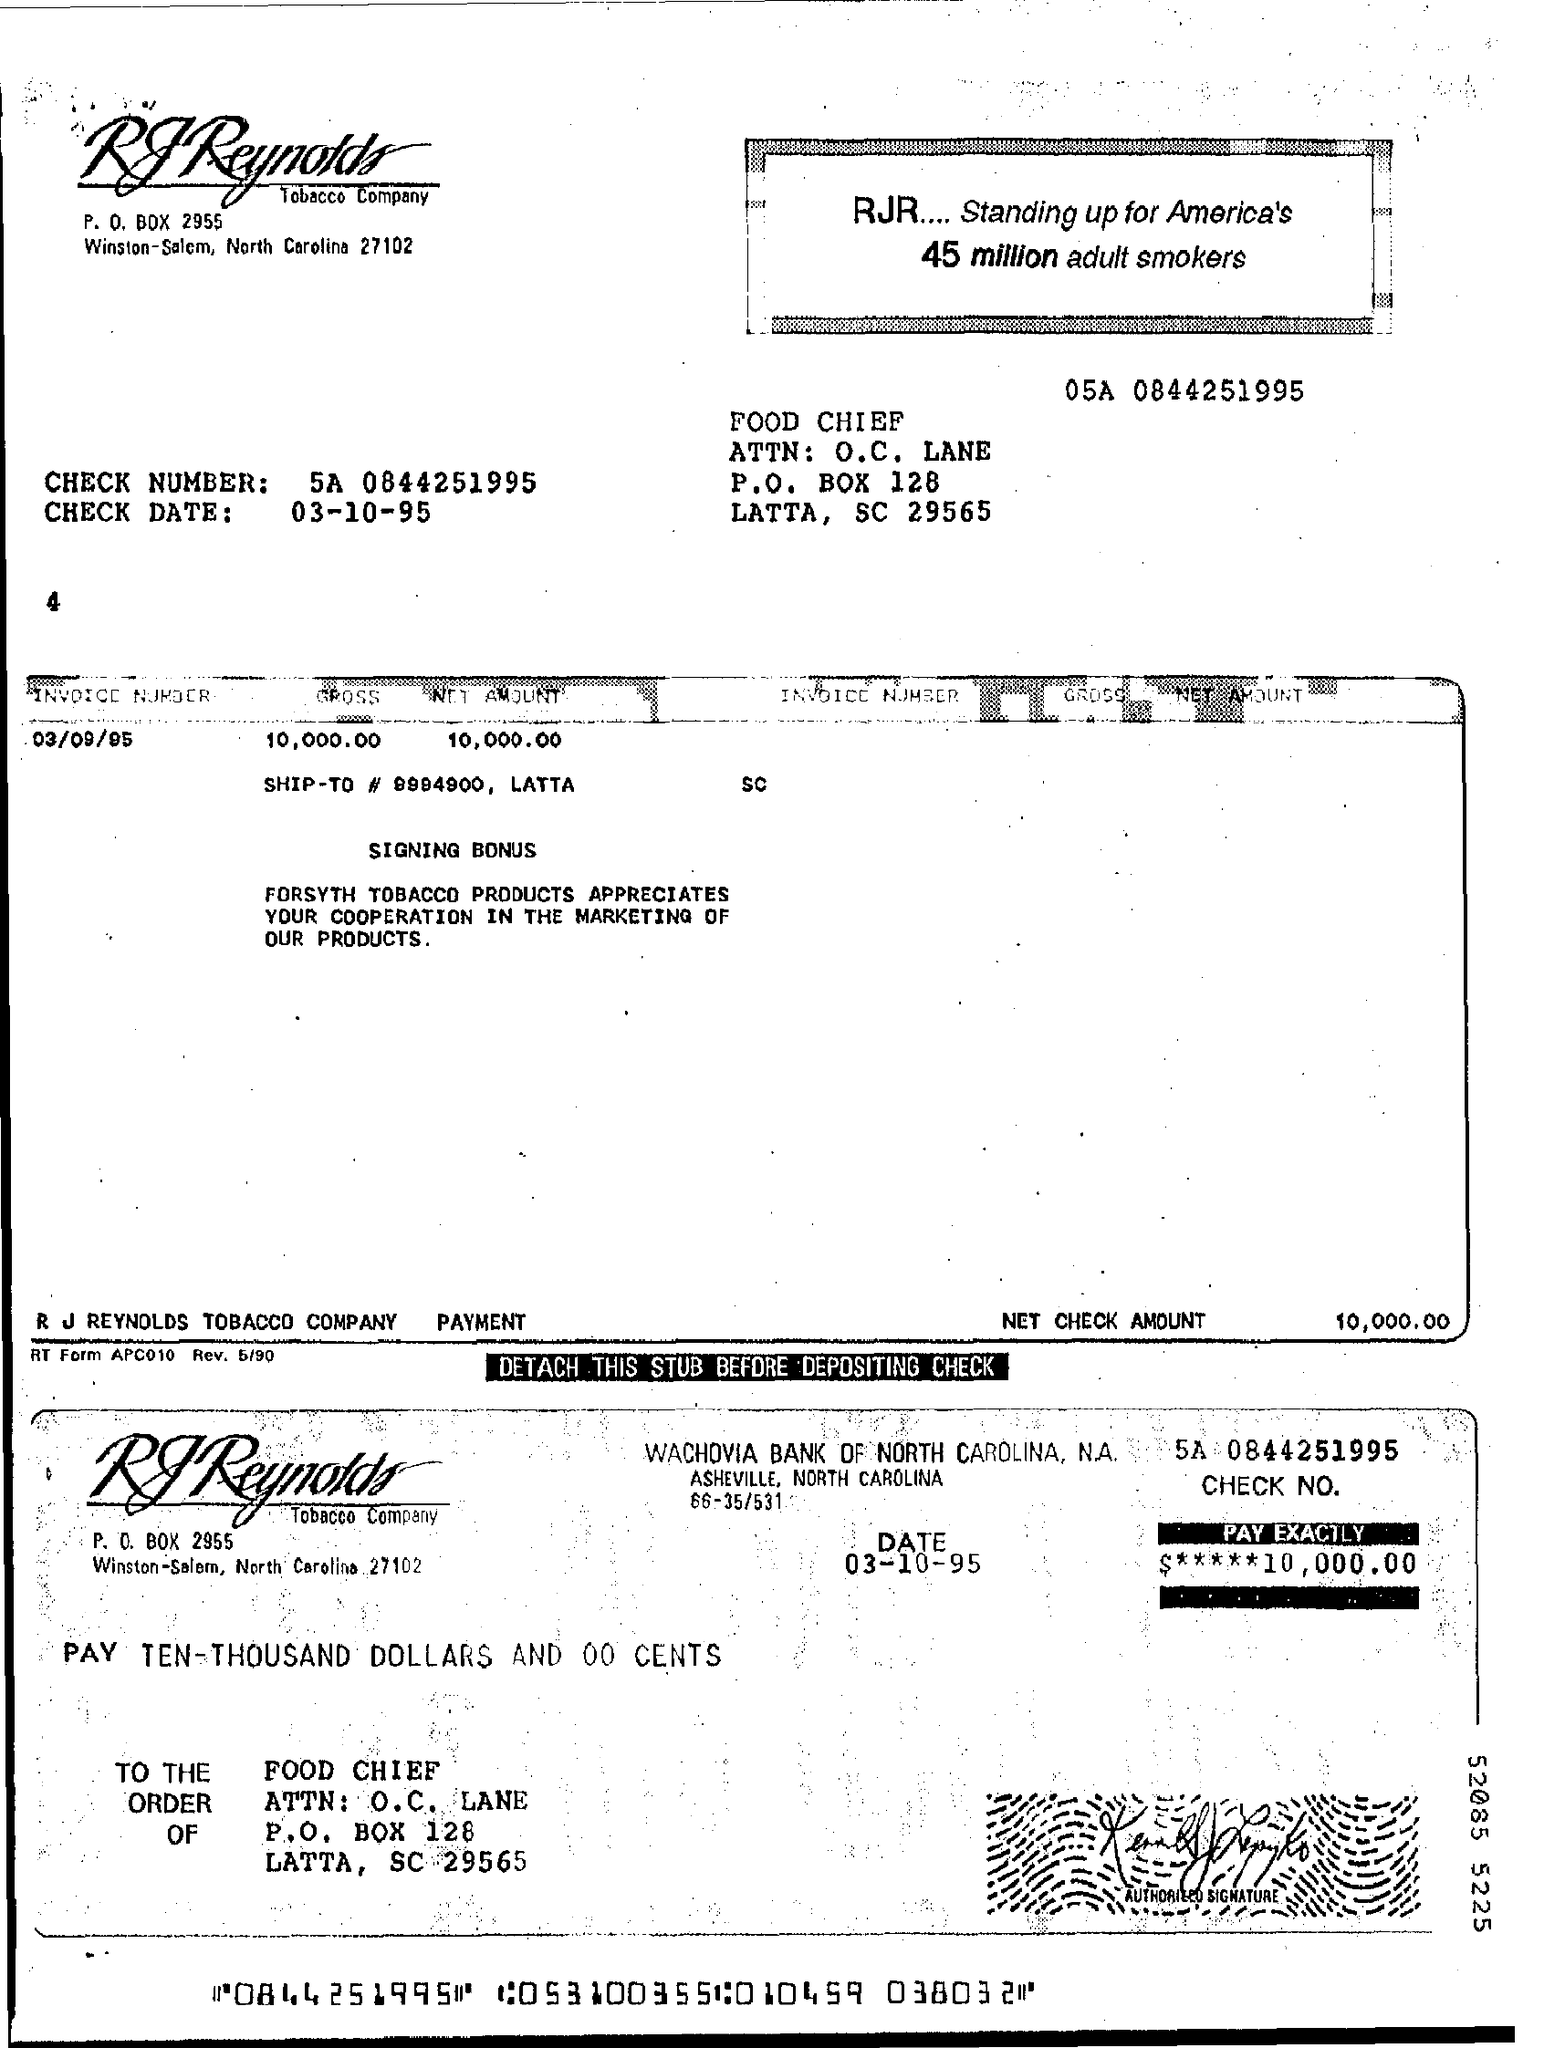Indicate a few pertinent items in this graphic. The invoice number is 03/09/95. The check date is 03-10-95. Please provide the check number, which is 5A followed by the digits 0844251995. 